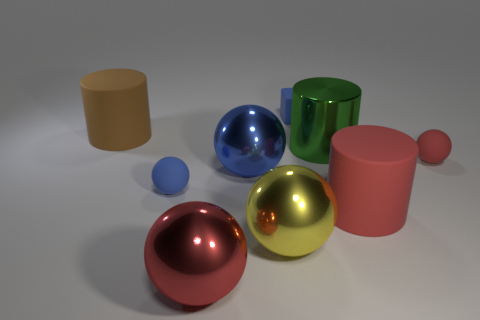Subtract all blue spheres. How many spheres are left? 3 Subtract all rubber cylinders. How many cylinders are left? 1 Add 1 big green cubes. How many objects exist? 10 Subtract 0 red blocks. How many objects are left? 9 Subtract all balls. How many objects are left? 4 Subtract 5 balls. How many balls are left? 0 Subtract all green blocks. Subtract all blue spheres. How many blocks are left? 1 Subtract all gray cylinders. How many blue balls are left? 2 Subtract all big blue metallic cylinders. Subtract all tiny blue spheres. How many objects are left? 8 Add 3 red spheres. How many red spheres are left? 5 